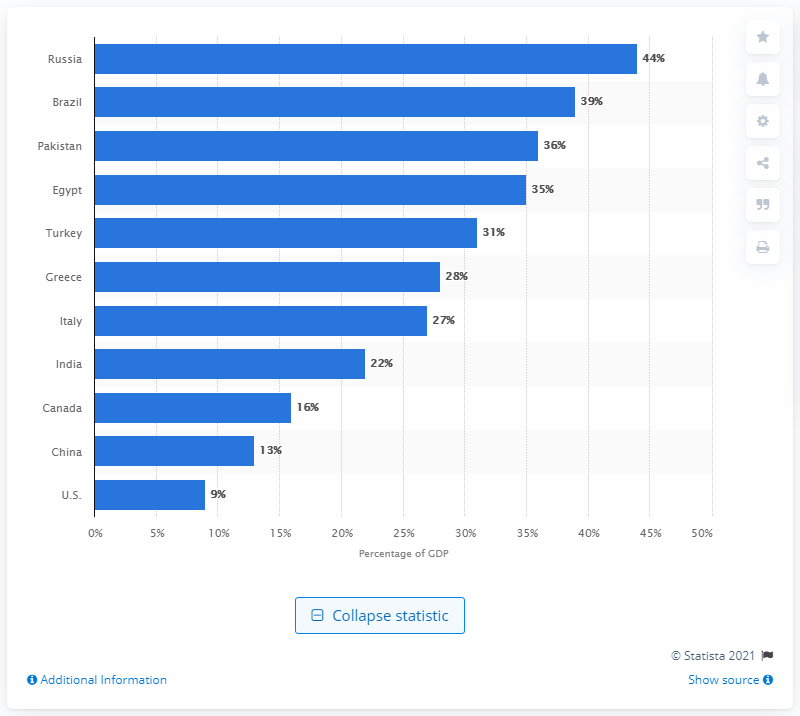Point out several critical features in this image. According to recent estimates, approximately 44% of Russia's GDP is comprised of the shadow economy. 